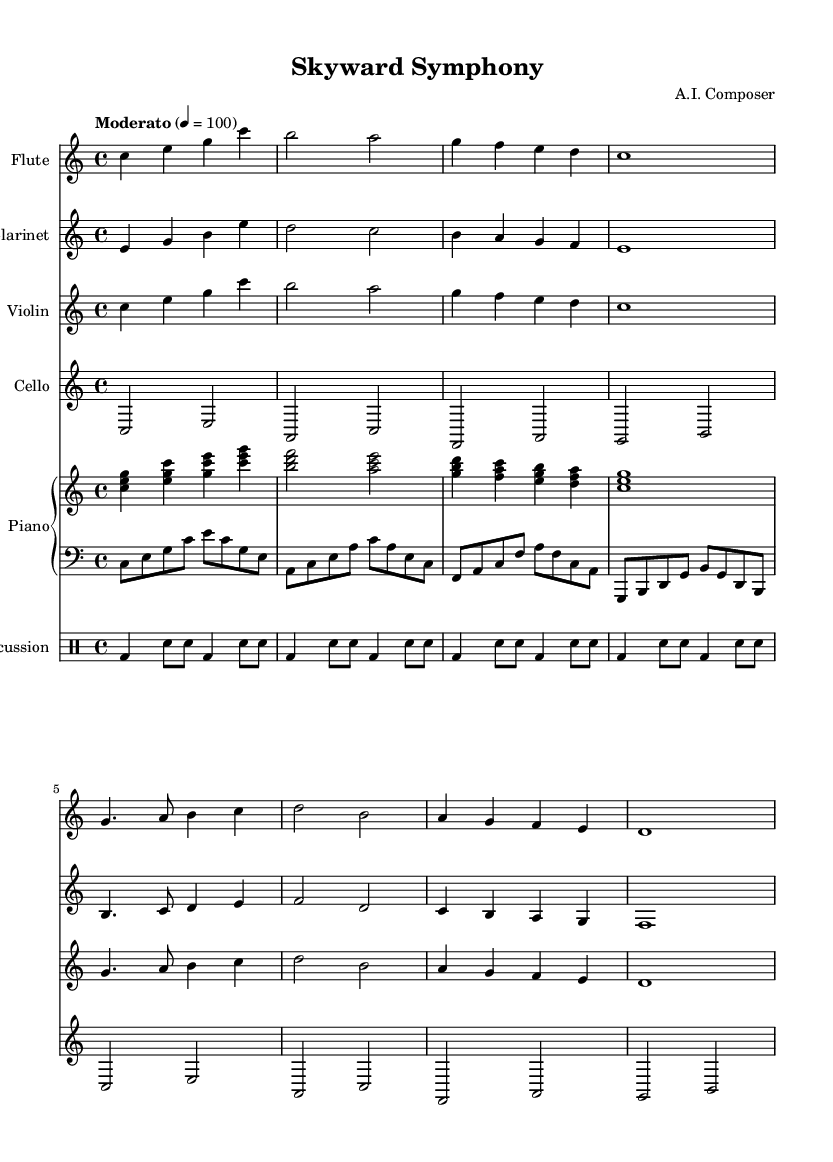What is the key signature of this music? The key signature is indicated at the beginning of the score, and it shows no sharps or flats, which corresponds to C major.
Answer: C major What is the time signature of this music? The time signature appears at the beginning of the piece, and it is noted as 4/4, meaning there are four beats in each measure.
Answer: 4/4 What is the tempo marking for this piece? The tempo is indicated in the score, stating "Moderato" and a metronome marking of 100, suggesting a moderate tempo.
Answer: Moderato How many instruments are used in this composition? By counting the listed staffs in the score, there are five distinct instruments: Flute, Clarinet, Violin, Cello, and Piano (which has two staffs) plus Percussion.
Answer: Five What is the rhythmic pattern of the percussion part? The percussion part consists of alternating bass drum and snare drum hits, as shown by the notation with varying note types indicating the pattern throughout the measures.
Answer: Alternating bass and snare Which instruments share the same melodic lines? Upon examining the flute and violin sections, it is clear that they share identical melodic motifs, indicated by their matching notations in the score.
Answer: Flute and Violin What type of modern sounds are incorporated in this contemporary classical work? Although specific sounds of modern aircraft are not directly notated in sheet music, the overall structure and instrumentation reflect the influence of aviation, which can be interpreted through the rhythms and dynamics used.
Answer: Aircraft sounds 